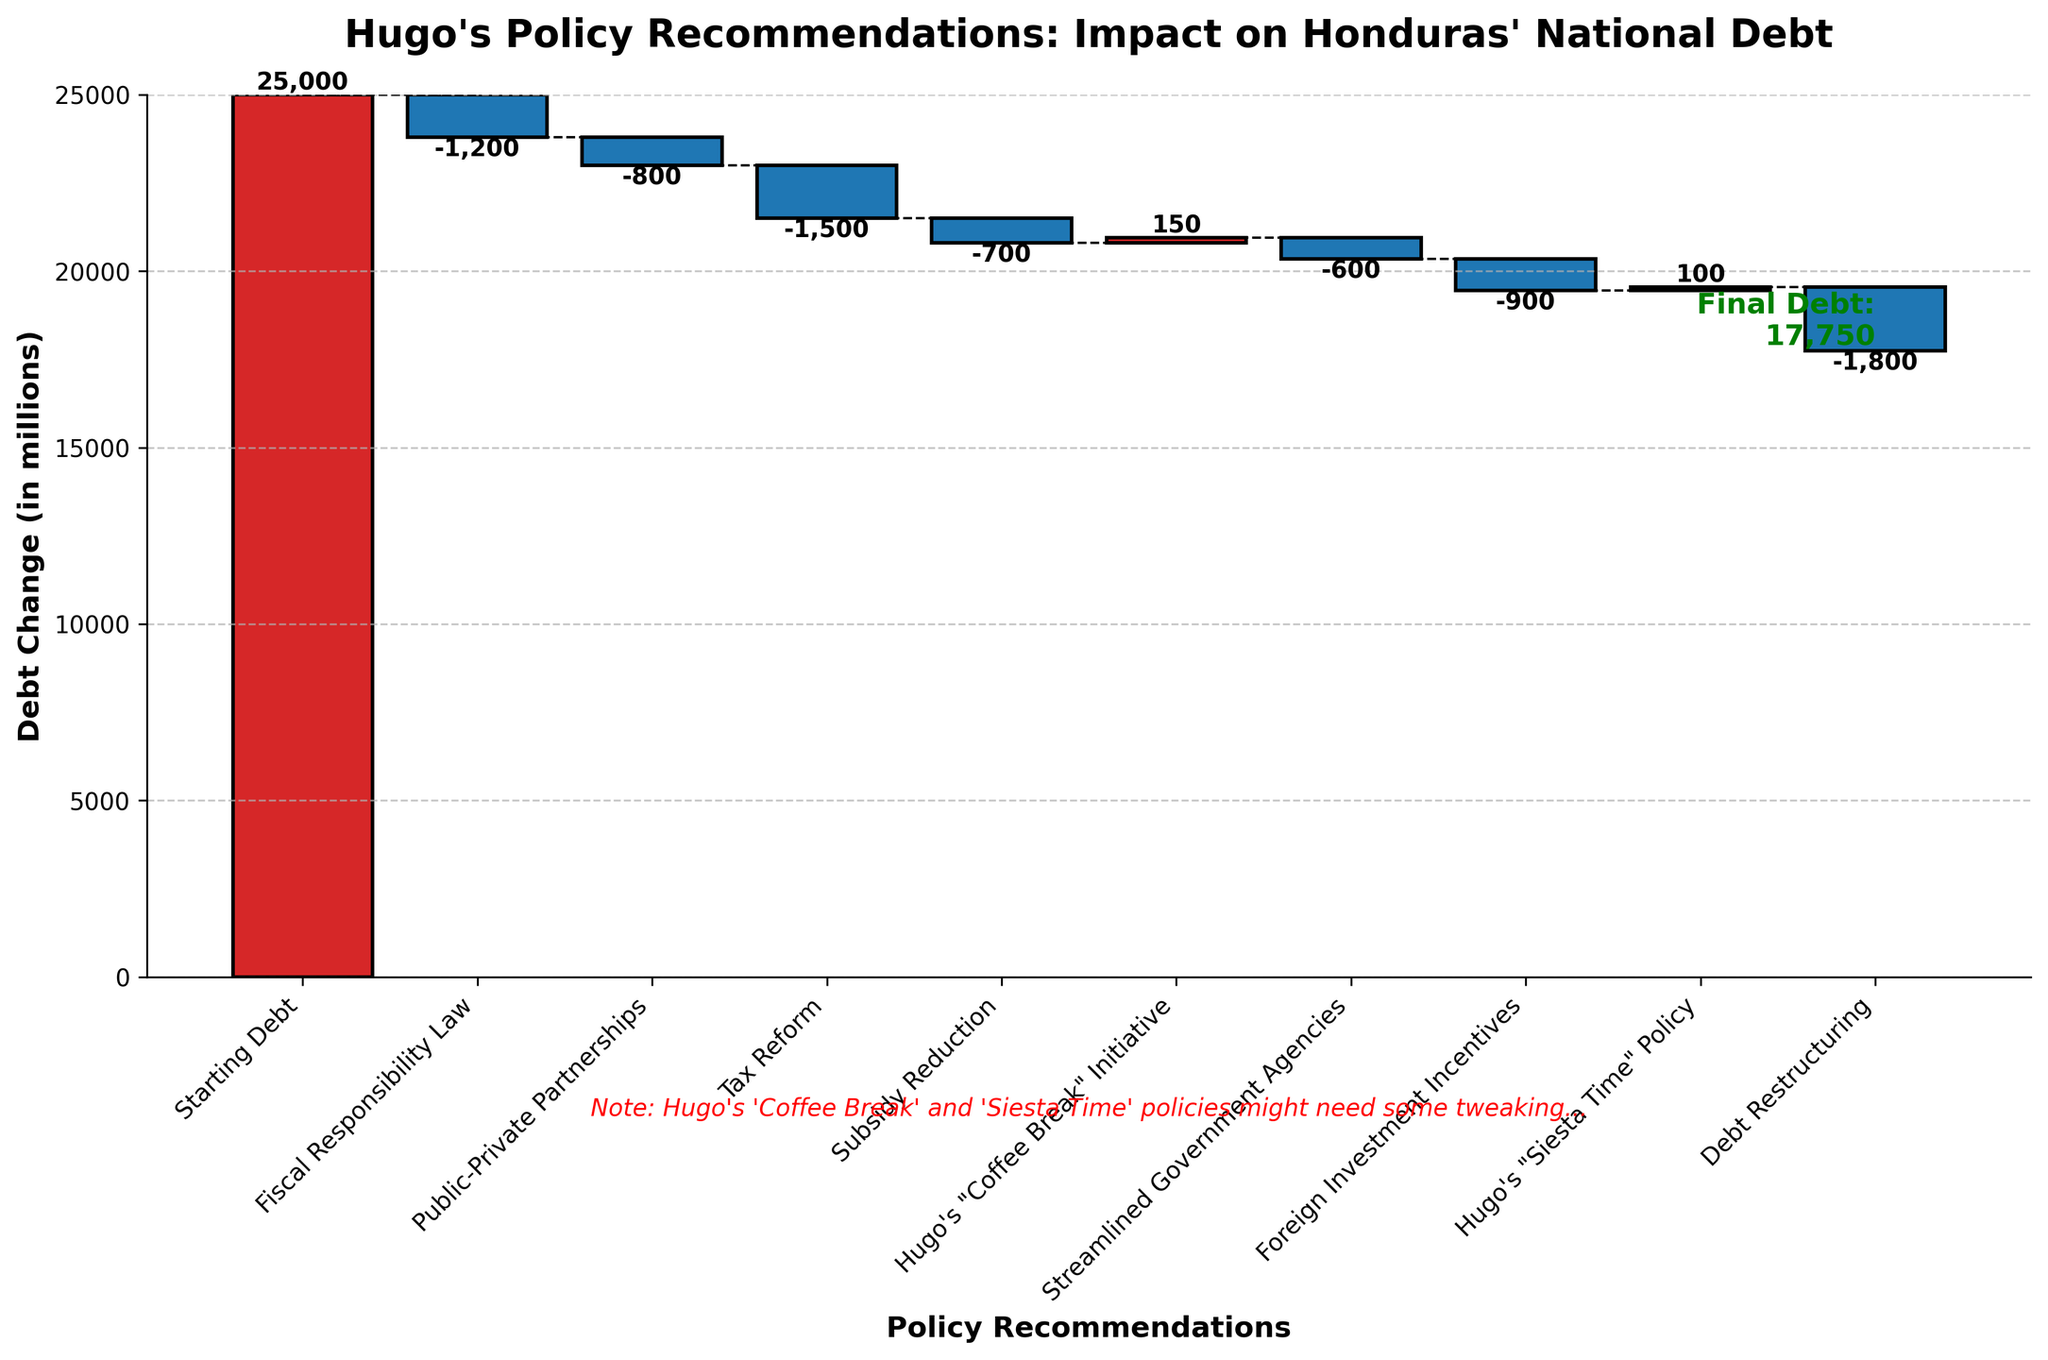What's the title of the plot? The title of the plot is displayed prominently at the top of the figure.
Answer: "Hugo's Policy Recommendations: Impact on Honduras' National Debt" How many policy recommendations are displayed in the figure? The x-axis lists each policy recommendation. Counting these labels will give the total number.
Answer: 9 Which policy results in the largest reduction in national debt? The bar with the most significant decrease visually represents the largest reduction. By observing the lengths of bars that are descending, we identify the "Debt Restructuring" category as having the most significant reduction.
Answer: Debt Restructuring What is the cumulative effect on the national debt after the "Tax Reform" policy? Find the position of the "Tax Reform" category in the figure and trace the cumulative sum line up to that point. "Tax Reform" is the third policy, and the cumulative debt should be the initial debt (25000) minus successive reductions and additions up to this category. Calculate \( 25000 - 1200 - 800 - 1500 \).
Answer: 21,500 What is the final debt after all the policies are implemented? The final debt value is shown at the end of the cumulative line, labeled on the right side of the chart.
Answer: 17,550 How does Hugo's "Coffee Break" Initiative affect the national debt? Check the value and direction of the bar labeled "Hugo's 'Coffee Break' Initiative." A positive value indicates an increase, and a negative value indicates a decrease.
Answer: It increases the debt by 150 million Compare the effects of "Public-Private Partnerships" and "Foreign Investment Incentives" on the national debt. Which one has a greater impact? Both bars need to be visually compared in terms of their lengths. Identify their values and compare their absolute impacts.
Answer: "Foreign Investment Incentives" has a greater impact with a reduction of 900 million versus 800 million from "Public-Private Partnerships." What is the net change in debt from policies labeled under Hugo's humorous initiatives? Identify both humorous policies: "Hugo's 'Coffee Break' Initiative" (150) and "Hugo's 'Siesta Time' Policy" (100). Sum their values to find the net change.
Answer: Increases debt by 250 million What is the difference in debt reduction between "Fiscal Responsibility Law" and "Streamlined Government Agencies"? Subtract the reduction caused by "Streamlined Government Agencies" from the reduction caused by "Fiscal Responsibility Law": \( 1200 - 600 \).
Answer: 600 million What is the cumulative debt reduction by the time the "Subsidy Reduction" policy is implemented? Calculate the cumulative reduction by summing the decreases up to and including the "Subsidy Reduction" category. This involves subtracting each sequential reduction from the starting debt: \( 25000 - 1200 - 800 - 1500 - 700 \).
Answer: 20,800 